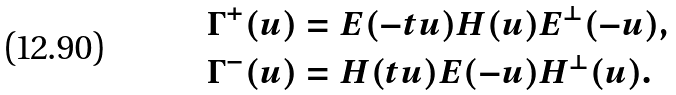Convert formula to latex. <formula><loc_0><loc_0><loc_500><loc_500>\Gamma ^ { + } ( u ) & = E ( - t u ) H ( u ) E ^ { \perp } ( - u ) , \\ \Gamma ^ { - } ( u ) & = H ( t u ) E ( - u ) H ^ { \perp } ( u ) .</formula> 